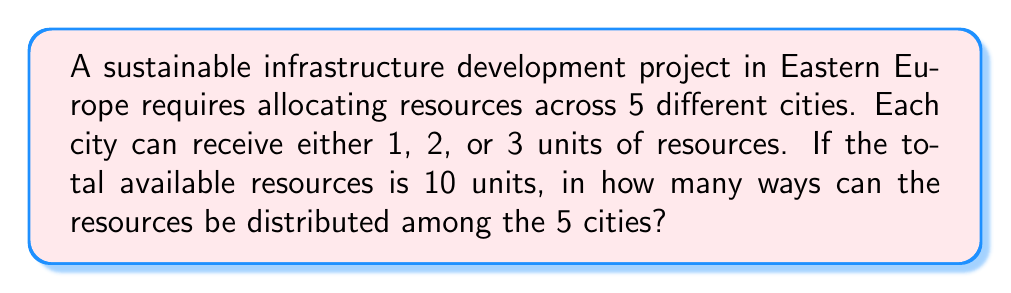Show me your answer to this math problem. Let's approach this step-by-step using combinatorics:

1) This is a problem of distributing 10 identical objects (resource units) into 5 distinct boxes (cities), where each box must contain at least 1 and at most 3 objects.

2) We can use the concept of stars and bars with restrictions. Let's represent each city by a bar (|) and each resource unit by a star (*).

3) We start by giving each city 1 resource unit:
   * | * | * | * | *

4) Now we have 5 resource units left to distribute among 5 cities, with each city able to receive 0, 1, or 2 more units.

5) This is equivalent to finding the number of solutions to the equation:
   $$x_1 + x_2 + x_3 + x_4 + x_5 = 5$$
   where $0 \leq x_i \leq 2$ for all $i$.

6) We can solve this using the generating function method. The generating function for each $x_i$ is:
   $$1 + z + z^2$$

7) The generating function for the entire problem is:
   $$(1 + z + z^2)^5$$

8) We need to find the coefficient of $z^5$ in this expansion.

9) Expanding $(1 + z + z^2)^5$ using the multinomial theorem:
   $$\sum_{i+j+k=5} \binom{5}{i,j,k} (1)^i (z)^j (z^2)^k$$

10) The coefficient of $z^5$ will come from terms where $j + 2k = 5$. The possible combinations are:
    - $(j,k) = (5,0), (3,1), (1,2)$

11) Summing these terms:
    $$\binom{5}{0,5,0} + \binom{5}{1,3,1} + \binom{5}{3,1,2} = 1 + 20 + 10 = 31$$

Therefore, there are 31 ways to distribute the resources.
Answer: 31 